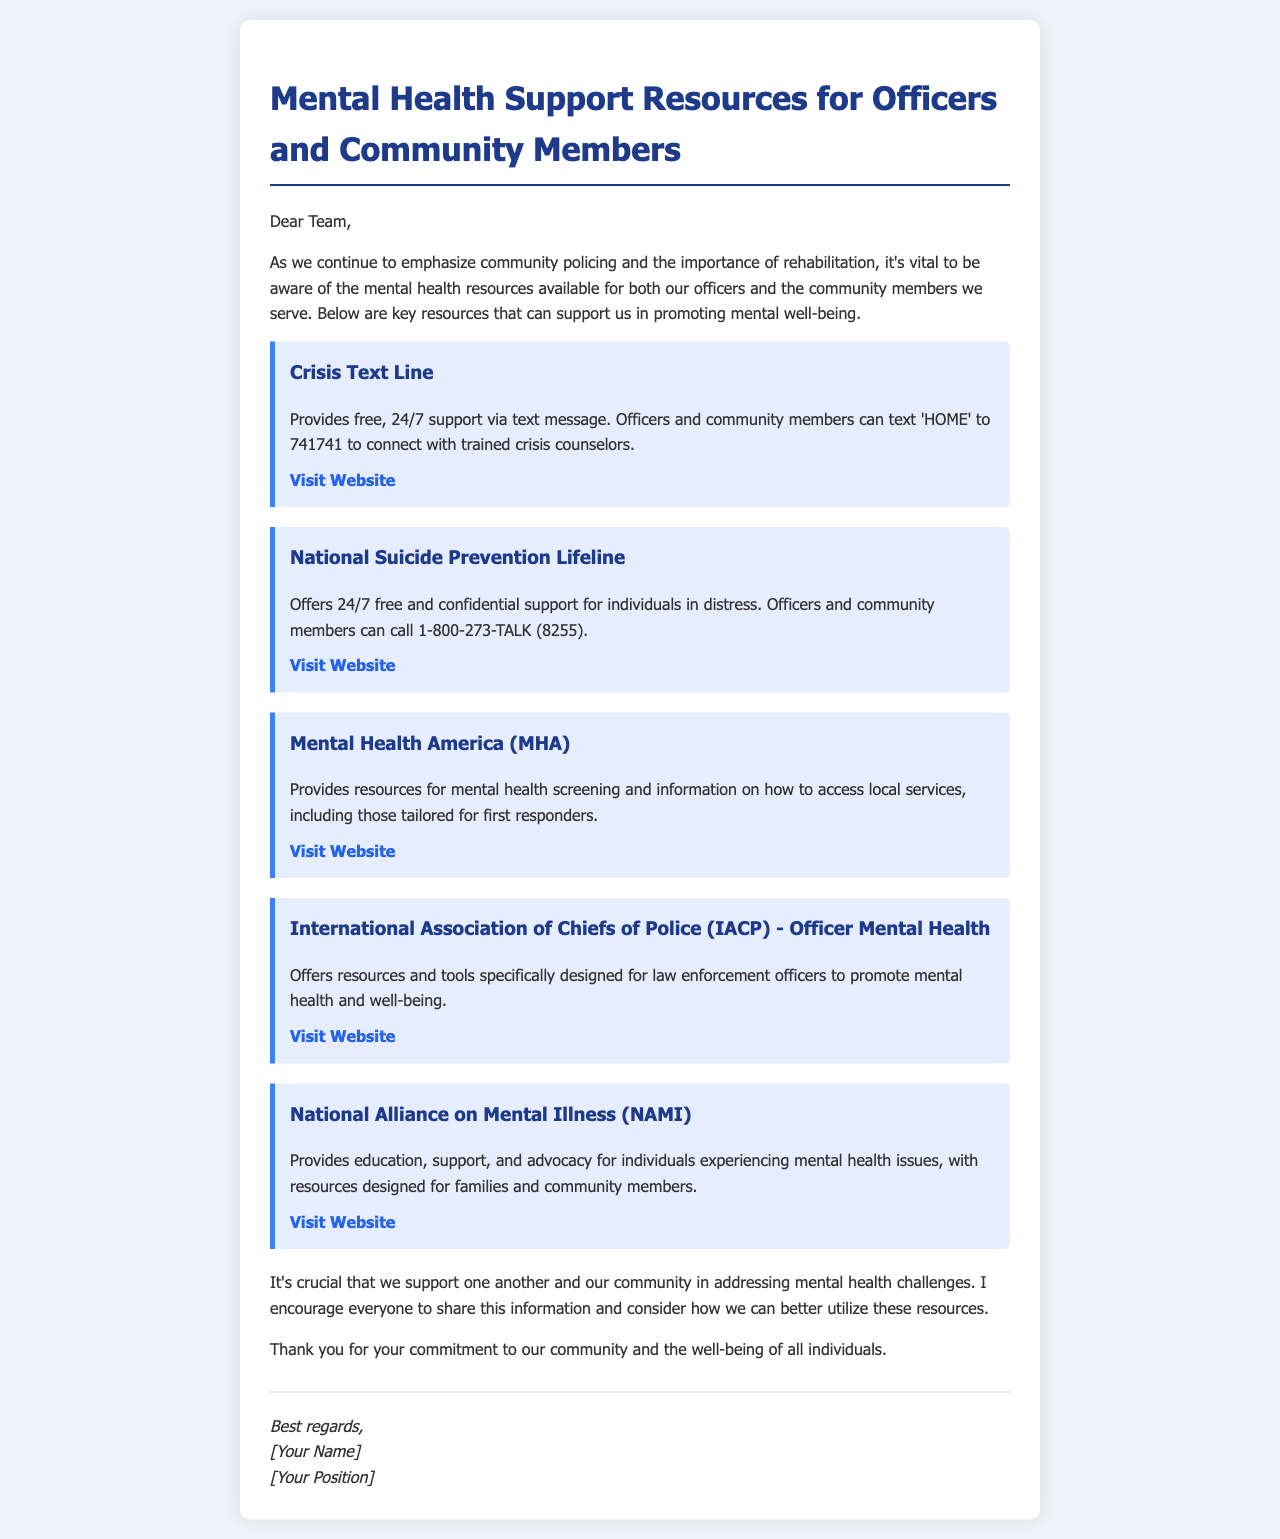What is the title of the email? The title is the main heading of the email that summarizes its purpose.
Answer: Mental Health Support Resources for Officers and Community Members What is the contact number for the National Suicide Prevention Lifeline? This number is mentioned in the description of the resource.
Answer: 1-800-273-TALK (8255) What do officers and community members text to reach the Crisis Text Line? This is stated as part of the Crisis Text Line description.
Answer: HOME Which organization offers resources specifically for law enforcement officers? The email mentions an organization that focuses on officer-specific resources.
Answer: International Association of Chiefs of Police (IACP) What type of support does Mental Health America (MHA) provide? This is described in the section about MHA in the email.
Answer: Resources for mental health screening and access to local services Why is it important to share the mental health resources? This point is made in the concluding remarks of the email.
Answer: To support one another and the community in addressing mental health challenges Who wrote the email? The email signature contains the author's name and position.
Answer: [Your Name] and [Your Position] 